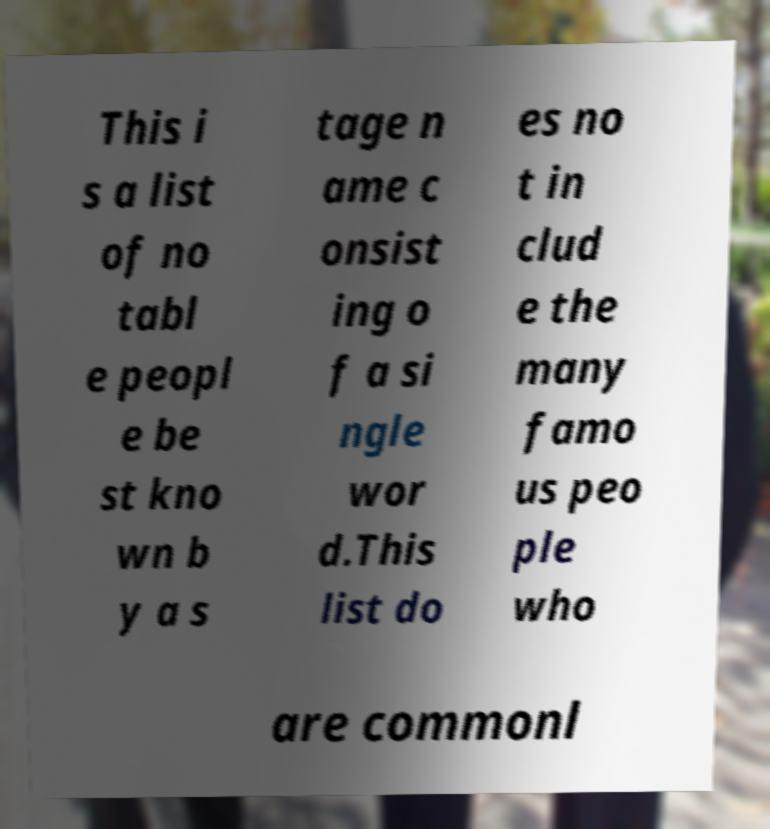There's text embedded in this image that I need extracted. Can you transcribe it verbatim? This i s a list of no tabl e peopl e be st kno wn b y a s tage n ame c onsist ing o f a si ngle wor d.This list do es no t in clud e the many famo us peo ple who are commonl 